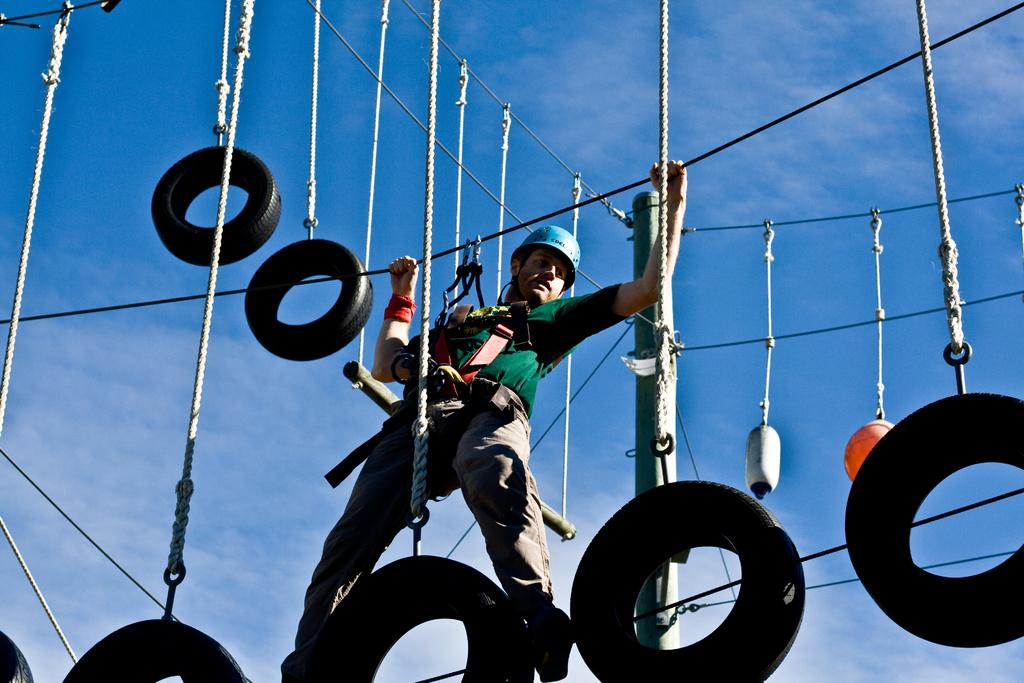What is hanging from the wires in the image? Ropes are hanging from the wires in the image. What is the person in the image doing? The person is walking on a rope in the image. What protective gear is the person wearing? The person is wearing a helmet. What is the person holding while walking on the rope? The person is holding ropes. What can be seen in the background of the image? Sky is visible in the background of the image. What type of weather is suggested by the clouds in the sky? The presence of clouds suggests that the weather might be partly cloudy. What type of sweater is the person wearing while walking on the rope? The person is not wearing a sweater in the image; they are wearing a helmet for protection. How many cables can be seen in the image? There are no cables visible in the image; only wires and ropes are present. 